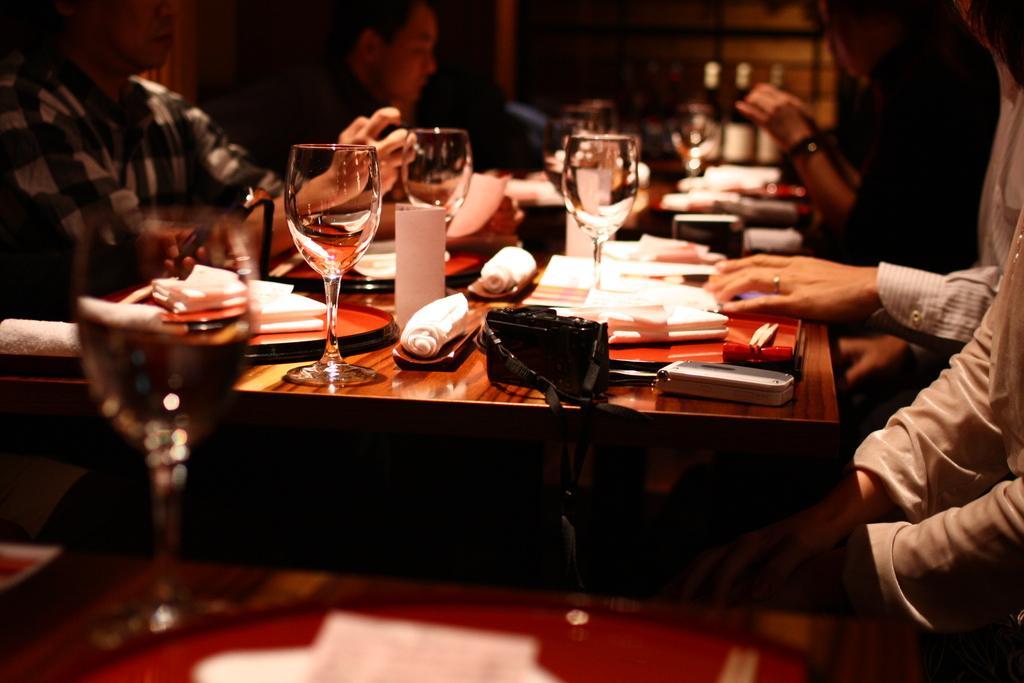Could you give a brief overview of what you see in this image? In the image we can see there is a table on which there are wine glass, napkin, purse, camera, mobile phone and the persons are sitting on chairs. 